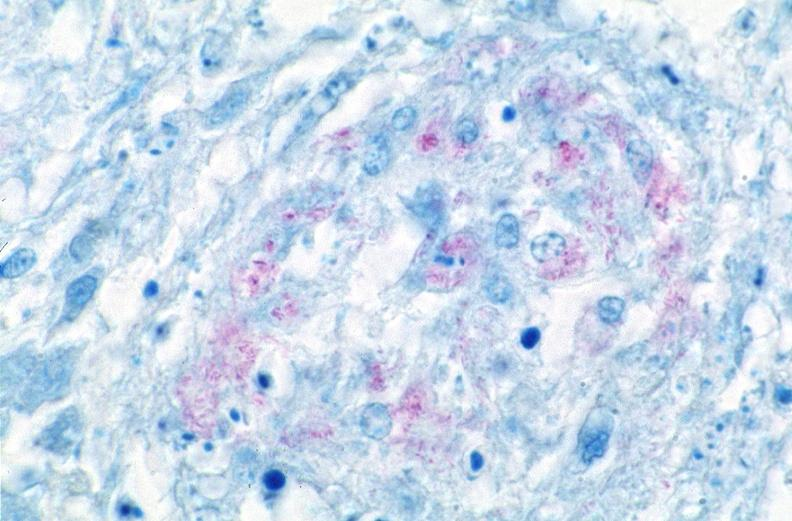what is present?
Answer the question using a single word or phrase. Respiratory 